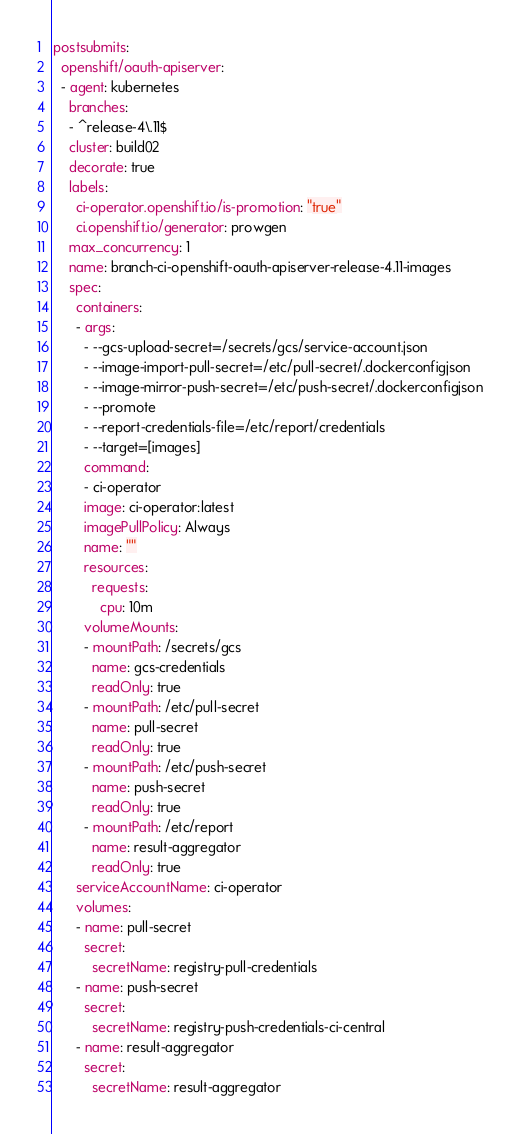<code> <loc_0><loc_0><loc_500><loc_500><_YAML_>postsubmits:
  openshift/oauth-apiserver:
  - agent: kubernetes
    branches:
    - ^release-4\.11$
    cluster: build02
    decorate: true
    labels:
      ci-operator.openshift.io/is-promotion: "true"
      ci.openshift.io/generator: prowgen
    max_concurrency: 1
    name: branch-ci-openshift-oauth-apiserver-release-4.11-images
    spec:
      containers:
      - args:
        - --gcs-upload-secret=/secrets/gcs/service-account.json
        - --image-import-pull-secret=/etc/pull-secret/.dockerconfigjson
        - --image-mirror-push-secret=/etc/push-secret/.dockerconfigjson
        - --promote
        - --report-credentials-file=/etc/report/credentials
        - --target=[images]
        command:
        - ci-operator
        image: ci-operator:latest
        imagePullPolicy: Always
        name: ""
        resources:
          requests:
            cpu: 10m
        volumeMounts:
        - mountPath: /secrets/gcs
          name: gcs-credentials
          readOnly: true
        - mountPath: /etc/pull-secret
          name: pull-secret
          readOnly: true
        - mountPath: /etc/push-secret
          name: push-secret
          readOnly: true
        - mountPath: /etc/report
          name: result-aggregator
          readOnly: true
      serviceAccountName: ci-operator
      volumes:
      - name: pull-secret
        secret:
          secretName: registry-pull-credentials
      - name: push-secret
        secret:
          secretName: registry-push-credentials-ci-central
      - name: result-aggregator
        secret:
          secretName: result-aggregator
</code> 